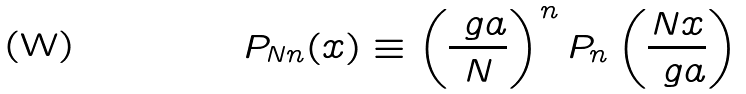Convert formula to latex. <formula><loc_0><loc_0><loc_500><loc_500>P _ { N n } ( x ) \equiv \left ( \frac { \ g a } { N } \right ) ^ { n } P _ { n } \left ( \frac { N x } { \ g a } \right )</formula> 